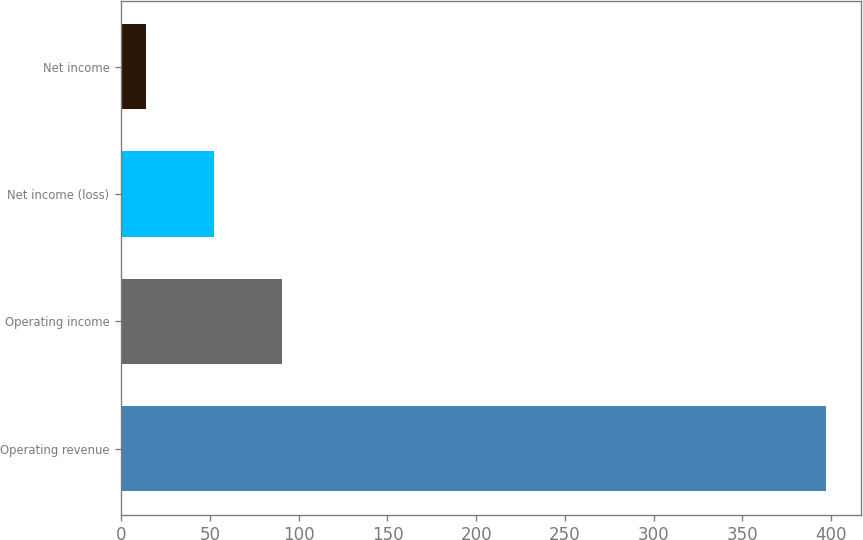Convert chart. <chart><loc_0><loc_0><loc_500><loc_500><bar_chart><fcel>Operating revenue<fcel>Operating income<fcel>Net income (loss)<fcel>Net income<nl><fcel>397.1<fcel>90.78<fcel>52.49<fcel>14.2<nl></chart> 